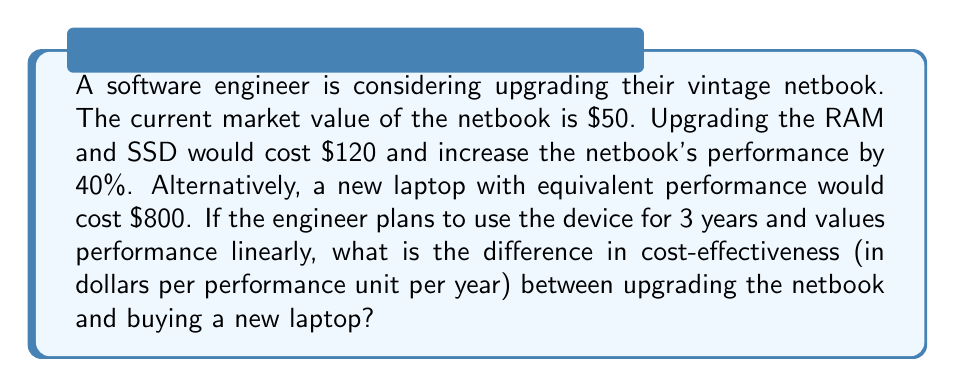What is the answer to this math problem? Let's approach this step-by-step:

1) First, let's define our units. We'll use a "performance unit" (PU) to measure the netbook's capabilities, with the current netbook as our baseline of 1 PU.

2) Upgrading the netbook:
   - Cost: $50 (current value) + $120 (upgrade cost) = $170
   - Performance: 1 PU * 1.40 = 1.4 PU
   - Lifespan: 3 years

3) Buying a new laptop:
   - Cost: $800
   - Performance: 1.4 PU (equivalent to upgraded netbook)
   - Lifespan: 3 years

4) Calculate cost-effectiveness for upgraded netbook:
   $$ \text{CE}_{\text{netbook}} = \frac{\text{Cost}}{\text{Performance} \times \text{Years}} = \frac{170}{1.4 \times 3} \approx 40.48 \text{ $/PU/year} $$

5) Calculate cost-effectiveness for new laptop:
   $$ \text{CE}_{\text{laptop}} = \frac{\text{Cost}}{\text{Performance} \times \text{Years}} = \frac{800}{1.4 \times 3} \approx 190.48 \text{ $/PU/year} $$

6) Calculate the difference in cost-effectiveness:
   $$ \Delta \text{CE} = \text{CE}_{\text{laptop}} - \text{CE}_{\text{netbook}} \approx 190.48 - 40.48 = 150 \text{ $/PU/year} $$
Answer: $150/PU/year 